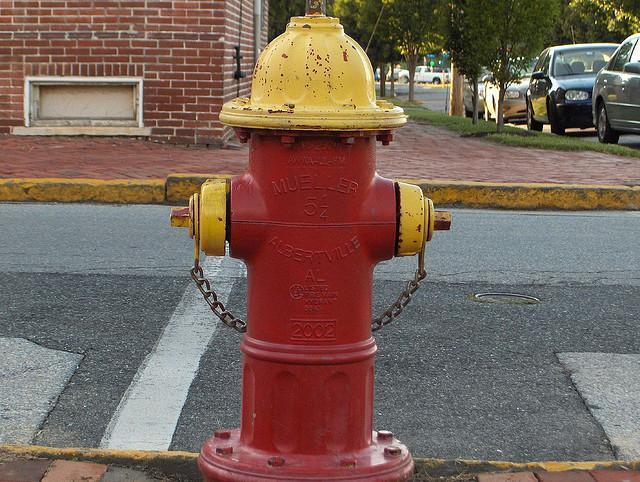The red color of fire hydrant represents what?
Select the accurate response from the four choices given to answer the question.
Options: Fire level, water quality, water force, none. Water force. 